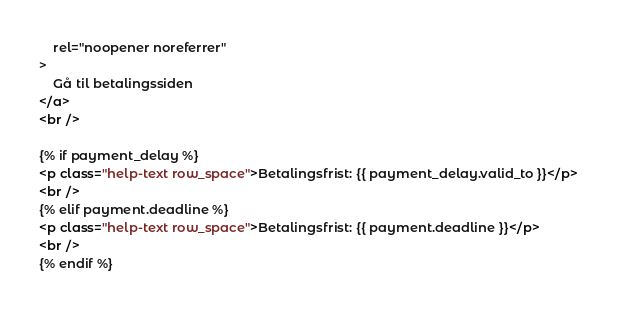Convert code to text. <code><loc_0><loc_0><loc_500><loc_500><_HTML_>    rel="noopener noreferrer"
>
    Gå til betalingssiden
</a>
<br />

{% if payment_delay %}
<p class="help-text row_space">Betalingsfrist: {{ payment_delay.valid_to }}</p>
<br />
{% elif payment.deadline %}
<p class="help-text row_space">Betalingsfrist: {{ payment.deadline }}</p>
<br />
{% endif %}
</code> 